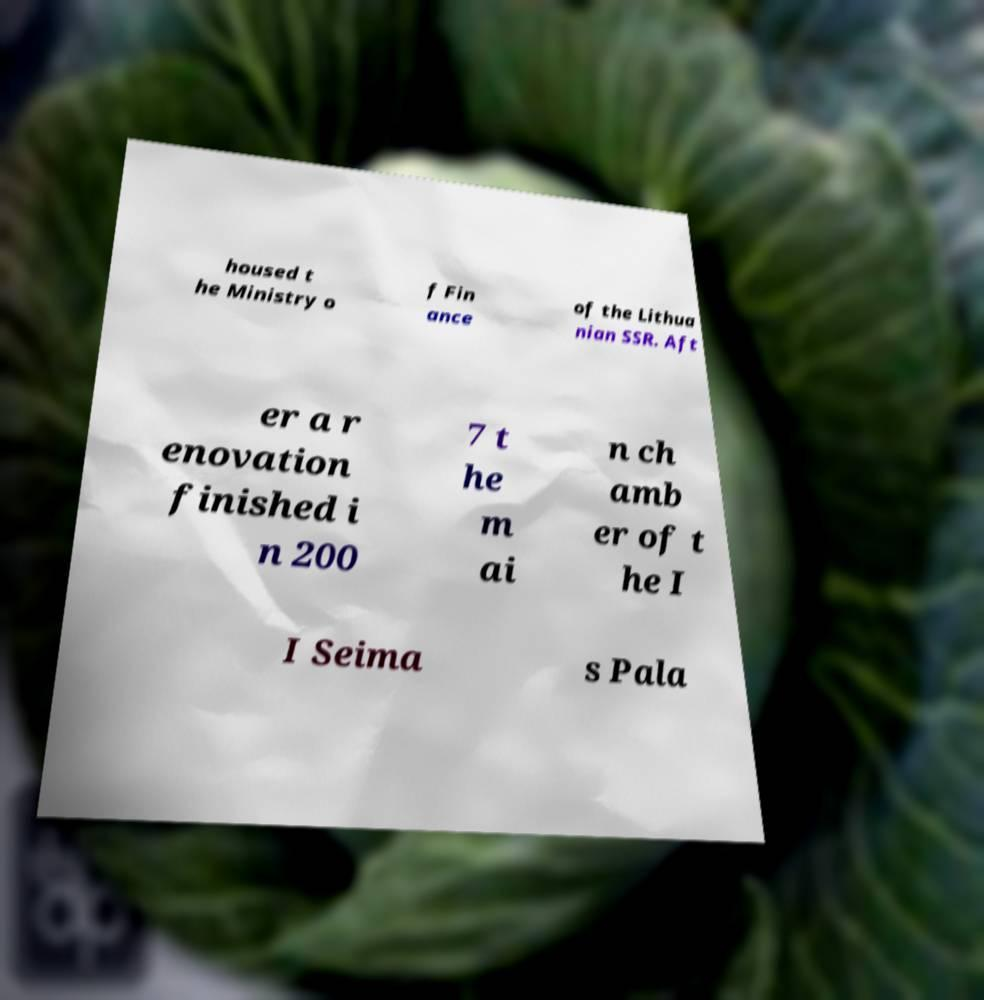Could you extract and type out the text from this image? housed t he Ministry o f Fin ance of the Lithua nian SSR. Aft er a r enovation finished i n 200 7 t he m ai n ch amb er of t he I I Seima s Pala 